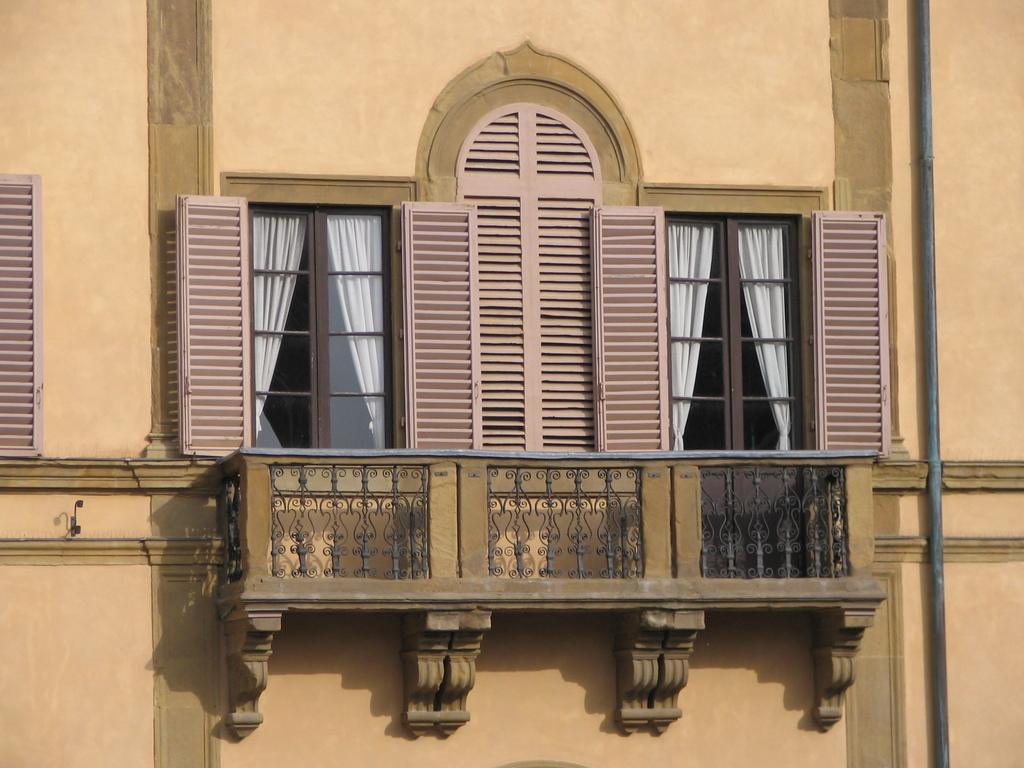Could you give a brief overview of what you see in this image? In this picture I can see there is railing and there are windows, they have curtains and there is a pipeline here at right side. 